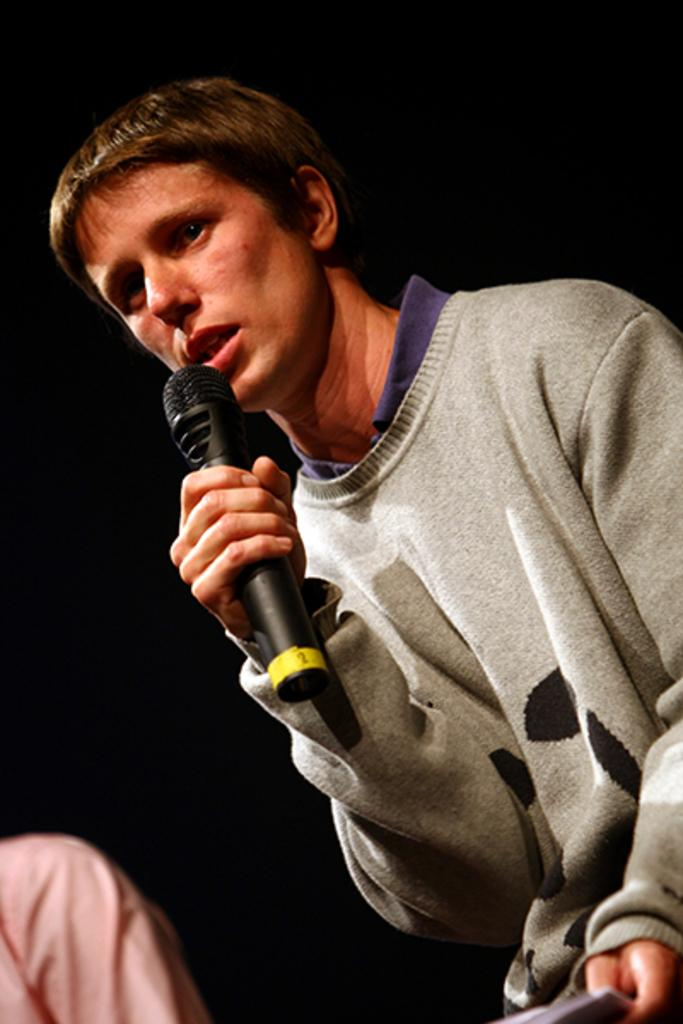Who is the person in the image? There is a man in the image. What is the man doing in the image? The man is talking in the image. How is the man talking in the image? The man is using a microphone to talk in the image. What type of honey is the man using to sweeten his speech in the image? There is no honey present in the image, and the man is not using honey to sweeten his speech. 